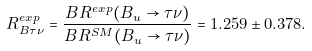Convert formula to latex. <formula><loc_0><loc_0><loc_500><loc_500>R ^ { e x p } _ { B \tau \nu } = \frac { B R ^ { e x p } ( B _ { u } \to \tau \nu ) } { B R ^ { S M } ( B _ { u } \to \tau \nu ) } = 1 . 2 5 9 \pm 0 . 3 7 8 .</formula> 